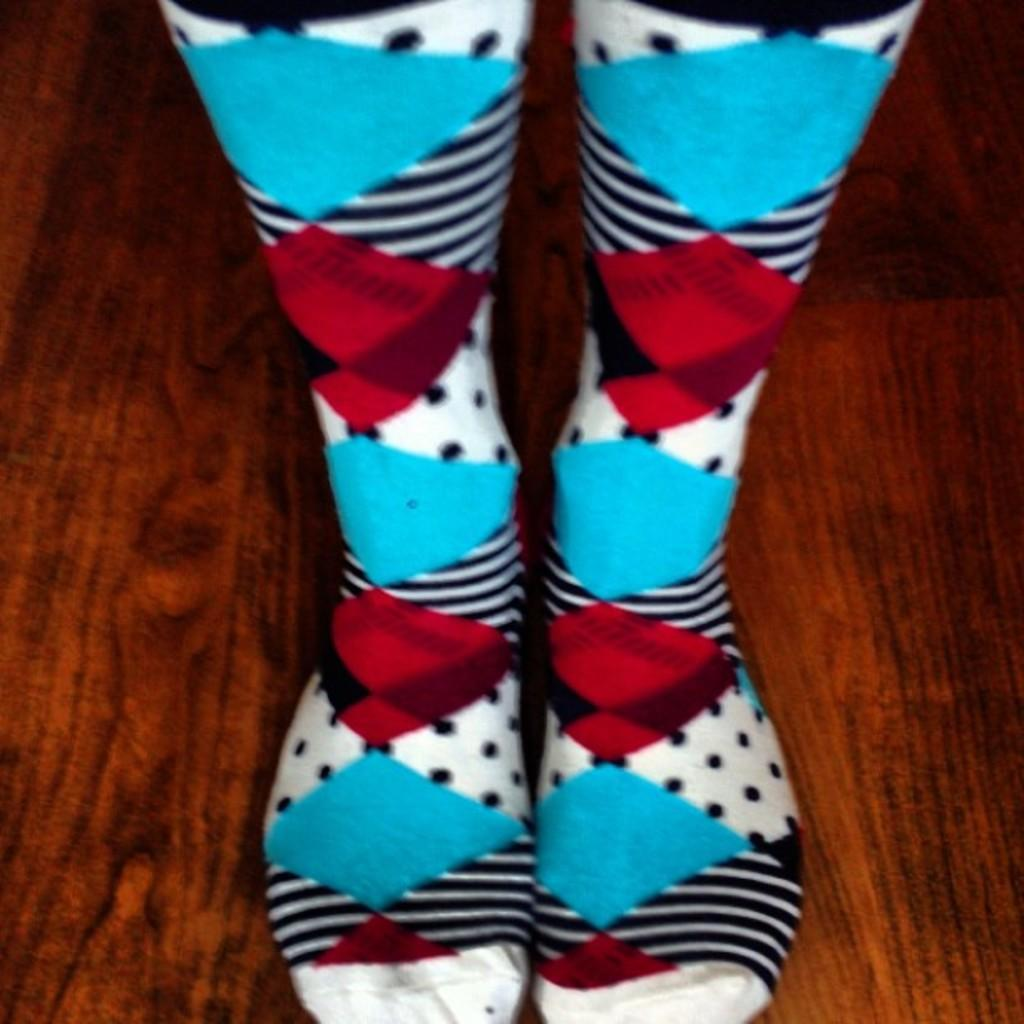What body parts can be seen in the image? There are legs visible in the image. What are the legs wearing? The legs are wearing socks. What type of surface is under the legs? The floor is visible in the image. What type of farm animal can be seen in the image? There are no farm animals present in the image; it only features legs wearing socks and a visible floor. 